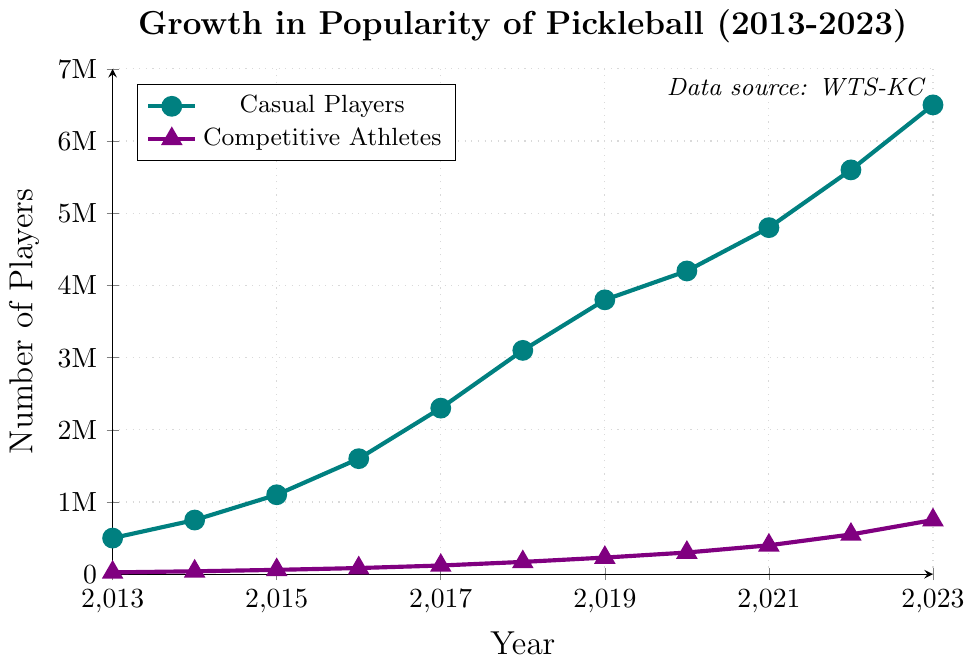What is the total increase in the number of casual players from 2013 to 2023? To find the total increase, subtract the number of casual players in 2013 from the number of casual players in 2023. The number of casual players in 2023 is 6,500,000 and in 2013 is 500,000. So, 6,500,000 - 500,000 = 6,000,000.
Answer: 6,000,000 In which year did the number of competitive athletes first exceed 200,000? By inspecting the line indicating competitive athletes, observe the year when the value first goes above 200,000. This occurs in the year 2019.
Answer: 2019 How much did the number of competitive athletes grow from 2016 to 2020? Calculate the difference between the number of competitive athletes in 2020 and 2016. The number of competitive athletes in 2020 is 300,000 and in 2016 is 85,000. So, 300,000 - 85,000 = 215,000.
Answer: 215,000 Which group had a higher growth rate from 2013 to 2023? Compare the growth rates by calculating the increase for each group and then dividing by the number of years. For casual players: (6,500,000 - 500,000) / 10 = 600,000 per year. For competitive athletes: (750,000 - 25,000) / 10 = 72,500 per year. The casual players have a higher growth rate.
Answer: Casual players Between 2018 and 2019, which group had a larger absolute increase in players? Calculate the difference in players from 2018 to 2019 for both groups. For casual players: 3,800,000 - 3,100,000 = 700,000. For competitive athletes: 230,000 - 170,000 = 60,000. The casual players had a larger absolute increase.
Answer: Casual players What is the difference in the number of casual players and competitive athletes in 2023? Subtract the number of competitive athletes in 2023 from the number of casual players in 2023. Casual players in 2023: 6,500,000, competitive athletes in 2023: 750,000. So, 6,500,000 - 750,000 = 5,750,000.
Answer: 5,750,000 In which year did the number of casual players surpass 3 million? Look for the year when the number of casual players exceeds 3 million for the first time. From the data, this occurs in 2018.
Answer: 2018 What is the average annual growth of competitive athletes between 2015 and 2020? Calculate the total increase over the period and then divide by the number of years. The number of competitive athletes in 2020 is 300,000 and in 2015 is 60,000. So, (300,000 - 60,000) / 5 = 48,000 per year.
Answer: 48,000 What color represents the casual players in the figure? Identify the color used for the line indicating casual players, which is shown visually where casual players are labeled. The color for casual players is teal (or a shade of green-blue).
Answer: Teal By how much did the number of casual players increase from 2019 to 2021? Calculate the difference between the number of casual players in 2021 and 2019. The number of casual players in 2021 is 4,800,000 and in 2019 is 3,800,000. So, 4,800,000 - 3,800,000 = 1,000,000.
Answer: 1,000,000 